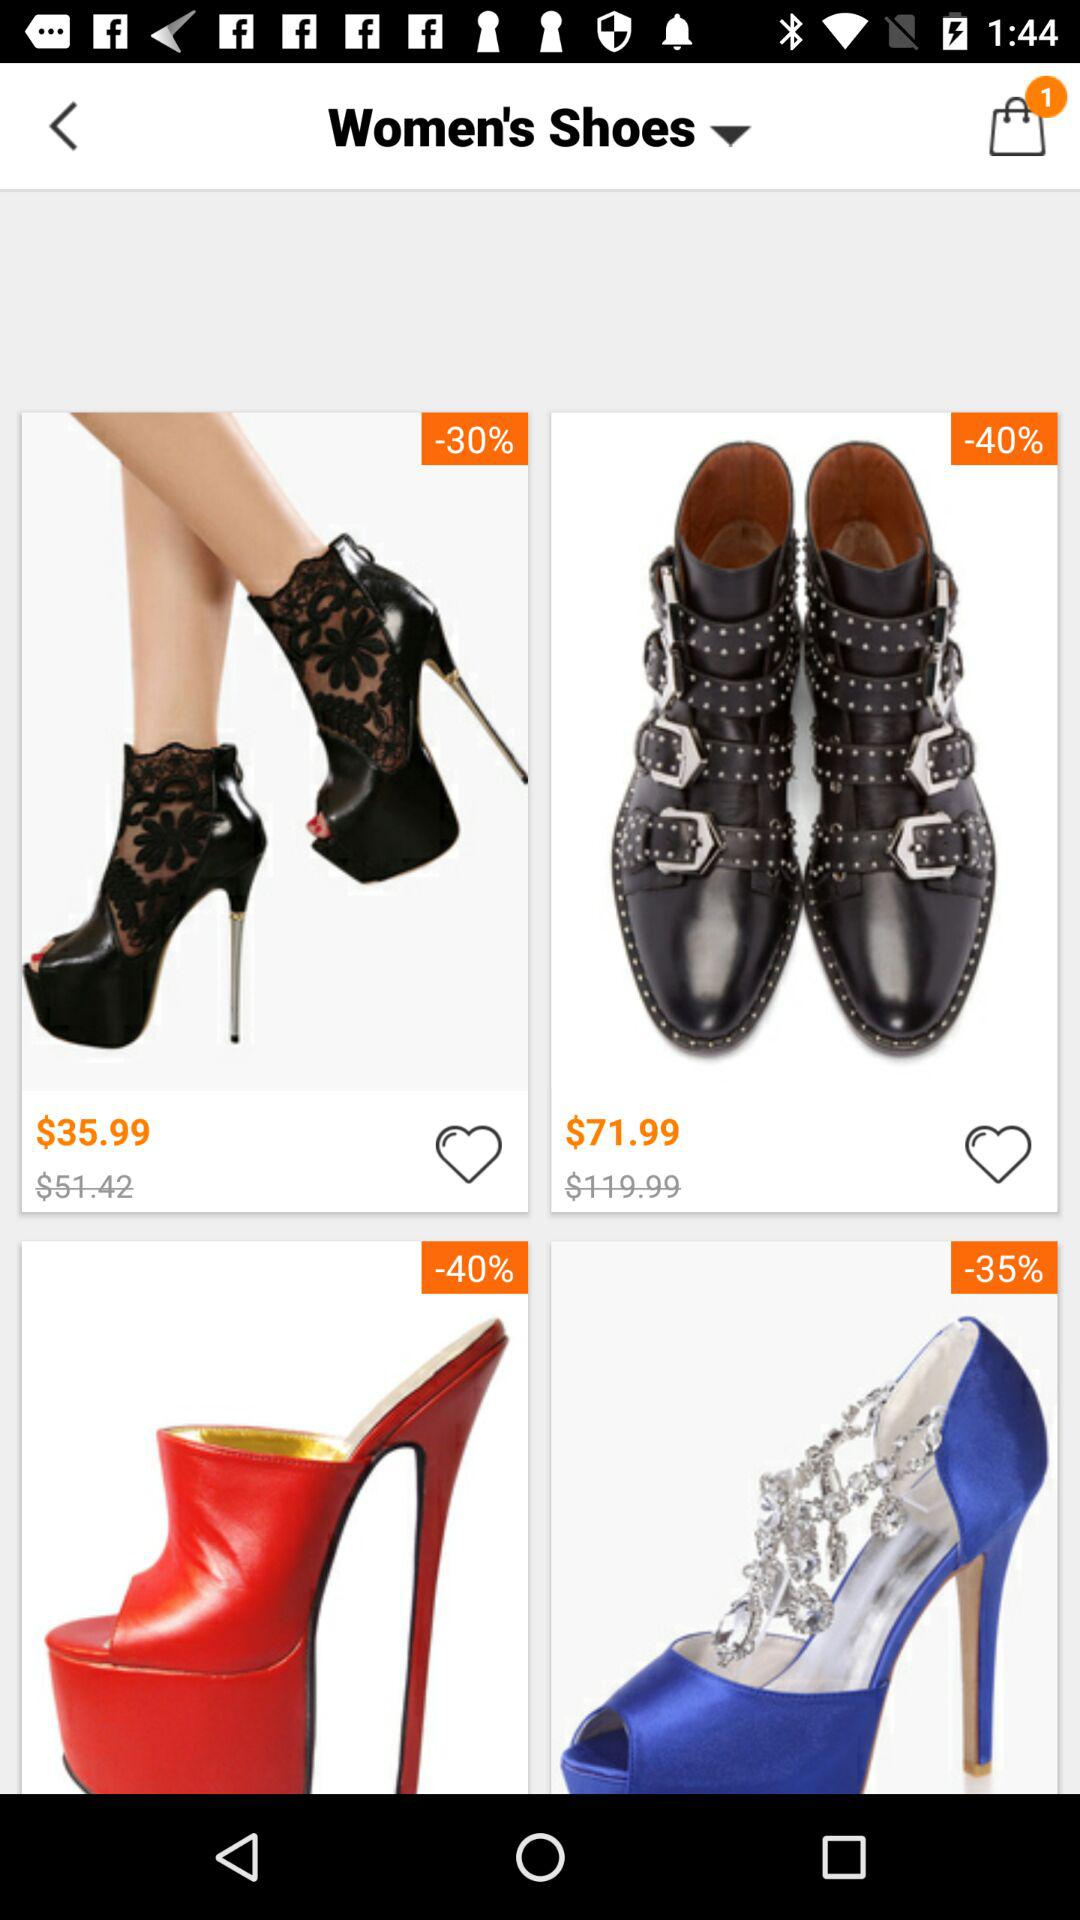How many items are there in the bag? There is 1 item in the bag. 